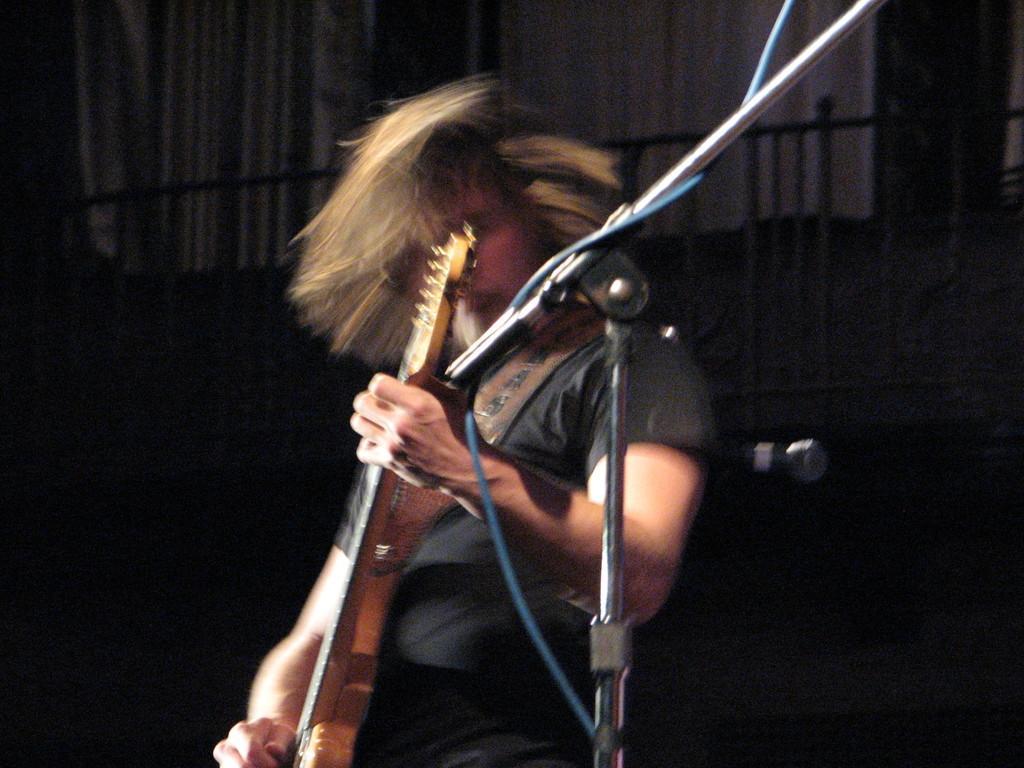Can you describe this image briefly? In the foreground of this image, there is a mic stand, cable and a man holding a guitar. In the dark background, there is railing, white curtain and a mic. 